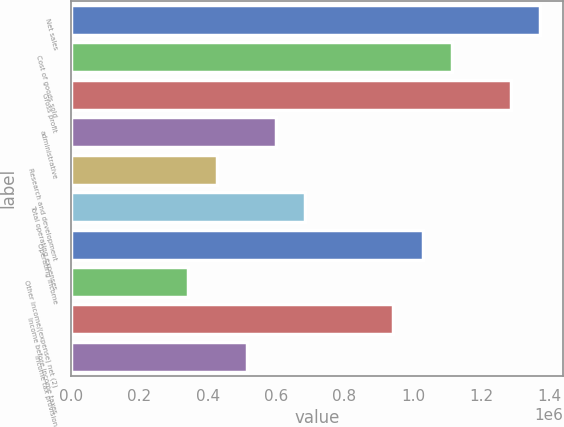Convert chart to OTSL. <chart><loc_0><loc_0><loc_500><loc_500><bar_chart><fcel>Net sales<fcel>Cost of goods sold<fcel>Gross profit<fcel>administrative<fcel>Research and development<fcel>Total operating expenses<fcel>Operating income<fcel>Other income/(expense) net (2)<fcel>Income before income taxes<fcel>Income tax provision<nl><fcel>1.37111e+06<fcel>1.11403e+06<fcel>1.28542e+06<fcel>599862<fcel>428473<fcel>685556<fcel>1.02833e+06<fcel>342778<fcel>942639<fcel>514167<nl></chart> 